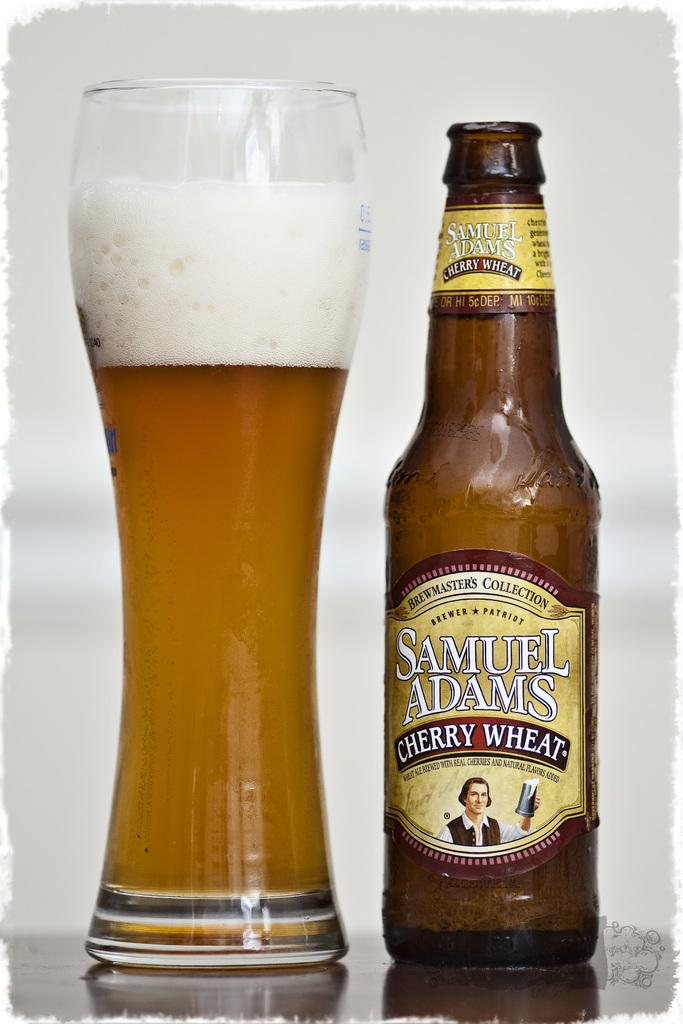<image>
Provide a brief description of the given image. A glass bottle of Samuel Adams Cherry Wheat Beer. 